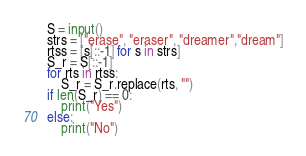Convert code to text. <code><loc_0><loc_0><loc_500><loc_500><_Python_>S = input()
strs = ["erase", "eraser", "dreamer","dream"]
rtss = [s[::-1] for s in strs]
S_r = S[::-1]
for rts in rtss:
    S_r = S_r.replace(rts, "")
if len(S_r) == 0:
    print("Yes")
else:
    print("No")</code> 